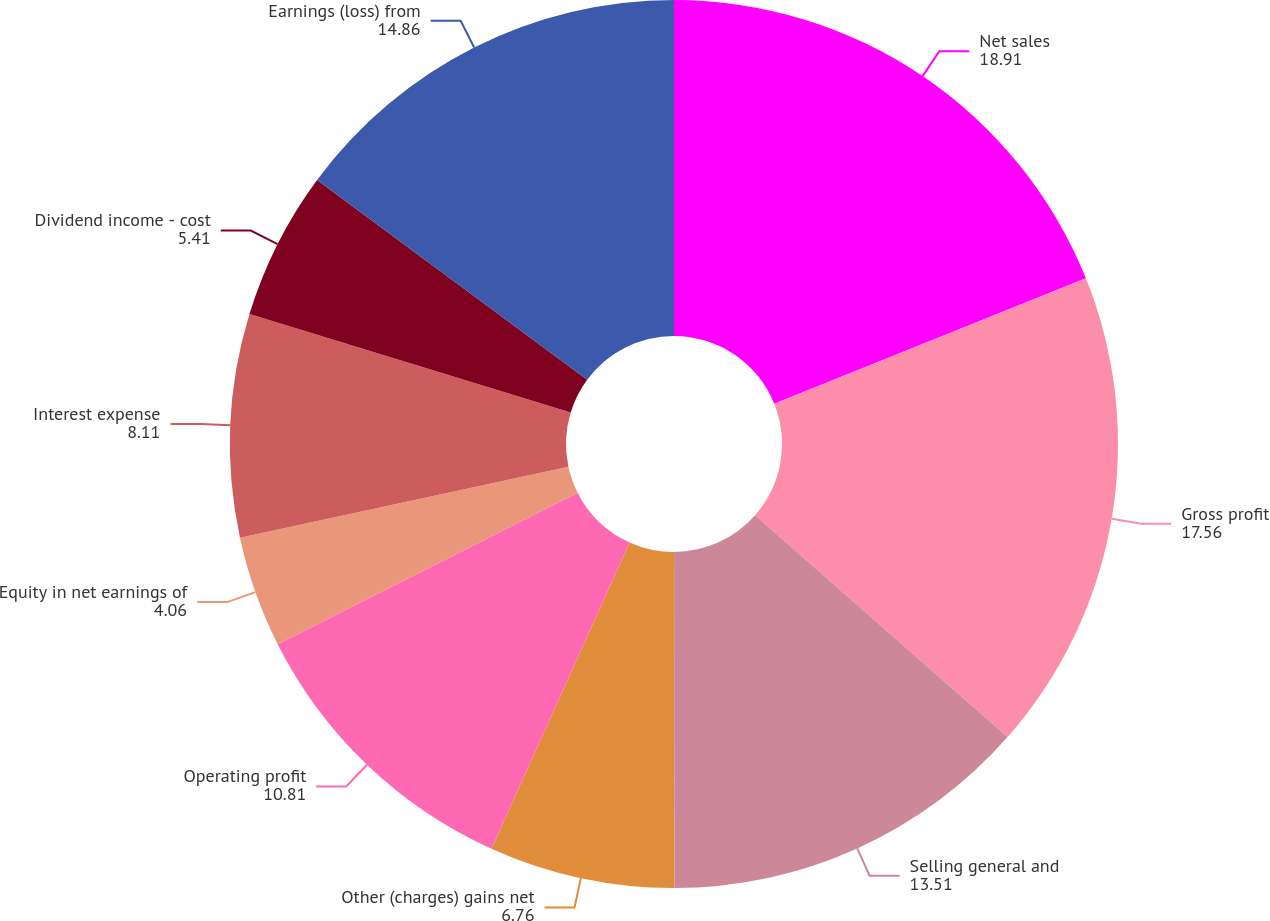Convert chart to OTSL. <chart><loc_0><loc_0><loc_500><loc_500><pie_chart><fcel>Net sales<fcel>Gross profit<fcel>Selling general and<fcel>Other (charges) gains net<fcel>Operating profit<fcel>Equity in net earnings of<fcel>Interest expense<fcel>Dividend income - cost<fcel>Earnings (loss) from<nl><fcel>18.91%<fcel>17.56%<fcel>13.51%<fcel>6.76%<fcel>10.81%<fcel>4.06%<fcel>8.11%<fcel>5.41%<fcel>14.86%<nl></chart> 